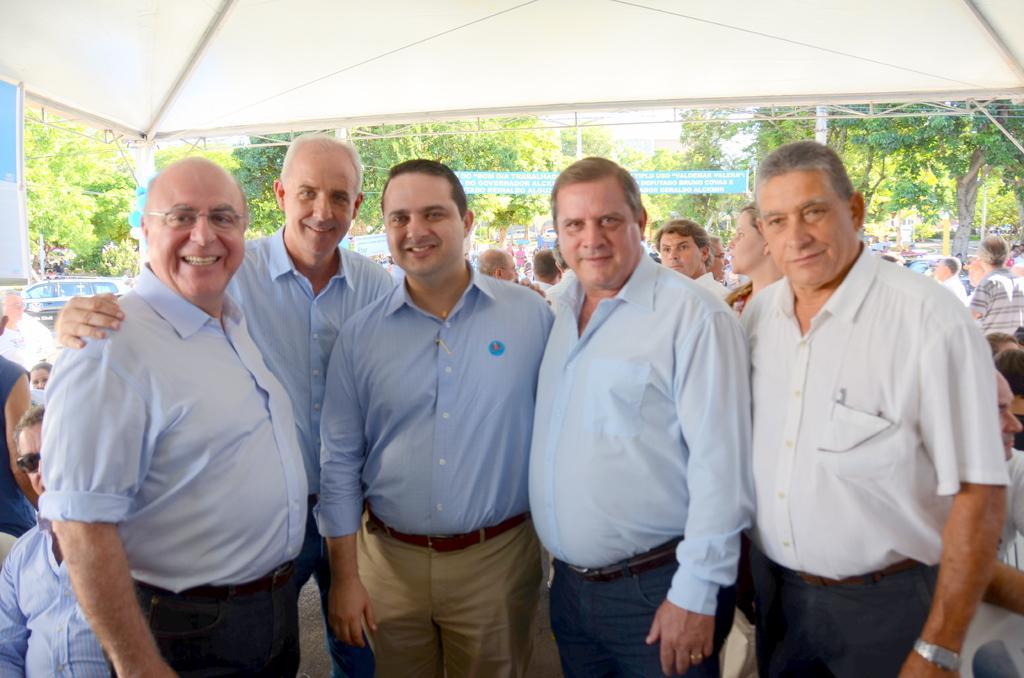Could you give a brief overview of what you see in this image? In this image I can see group of people standing, the person at right is wearing white shirt, black pant. Background I can see few other persons, some are sitting and some are standing, trees in green color, a tent in white color and the sky is also in white color. 